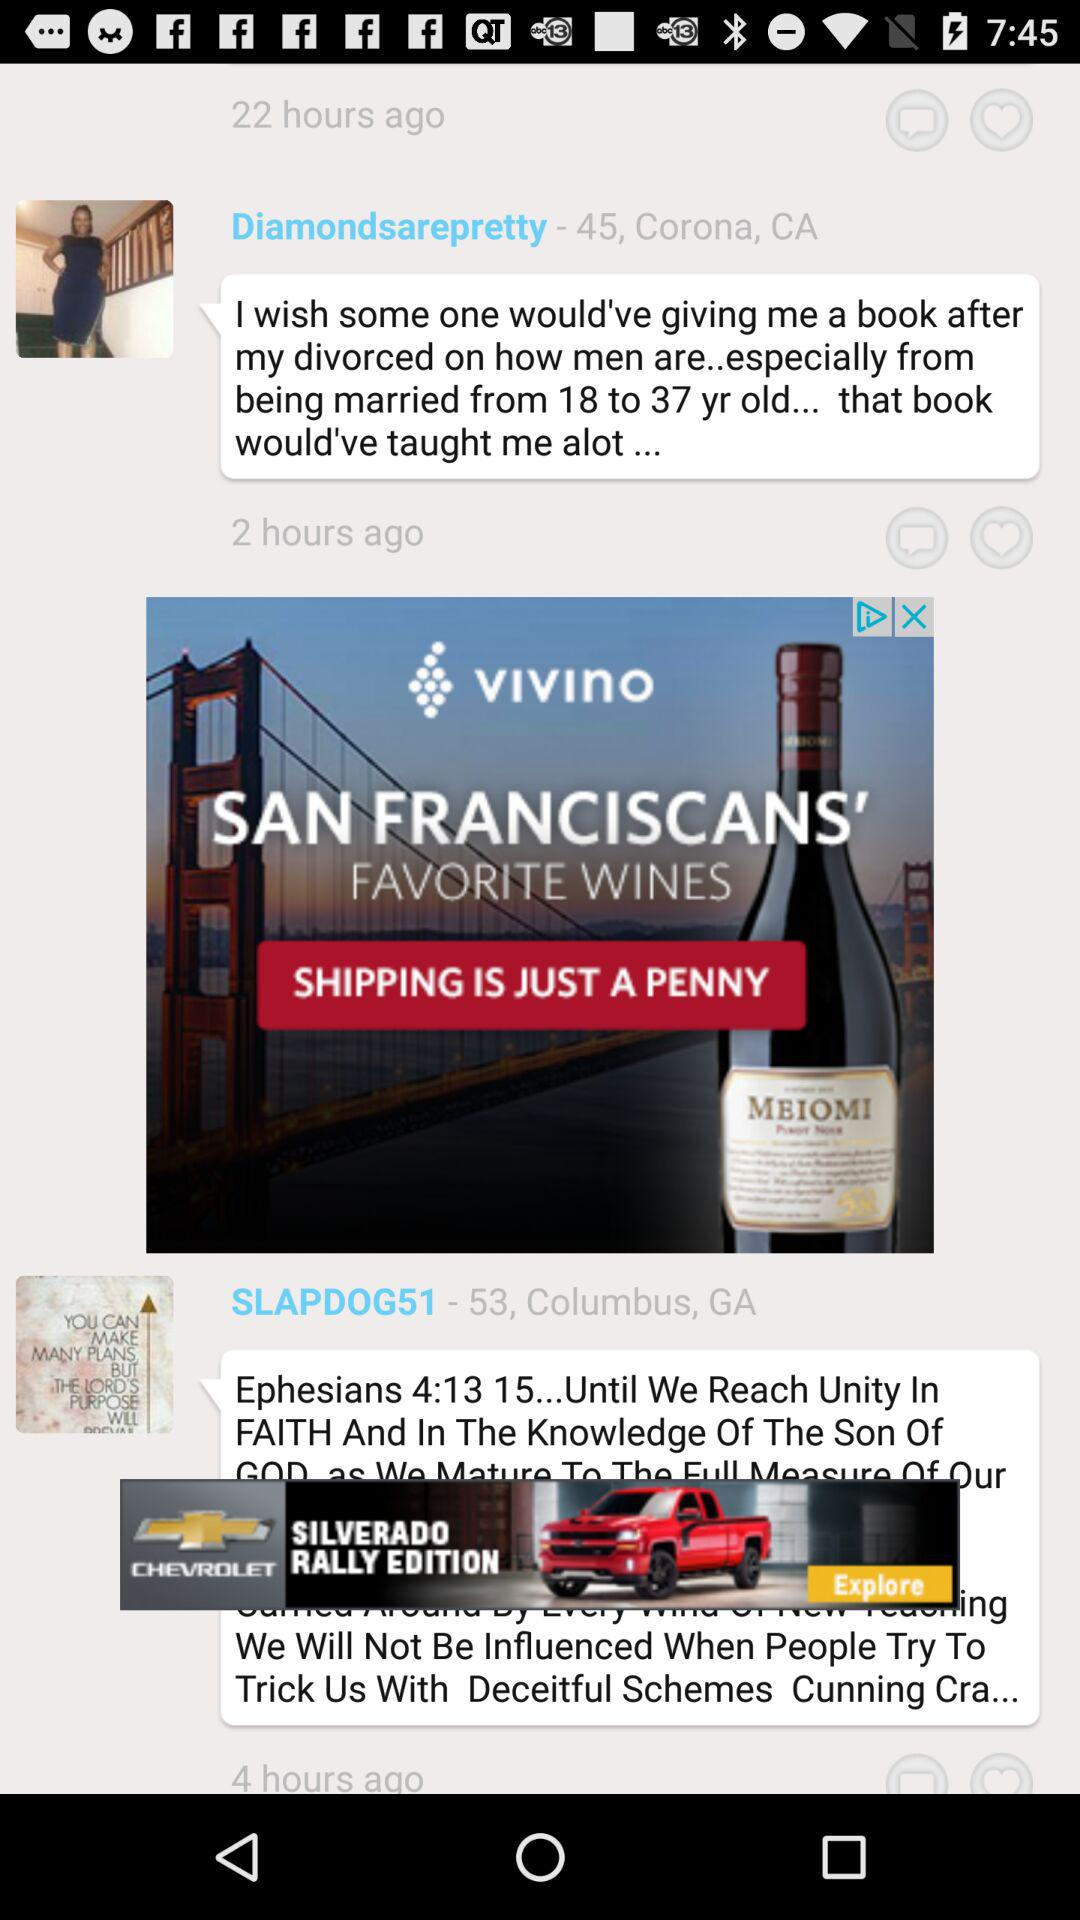Which city is "SLAPDOG51" from? "SLAPDOG51" is from Columbus. 